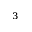Convert formula to latex. <formula><loc_0><loc_0><loc_500><loc_500>^ { 3 }</formula> 